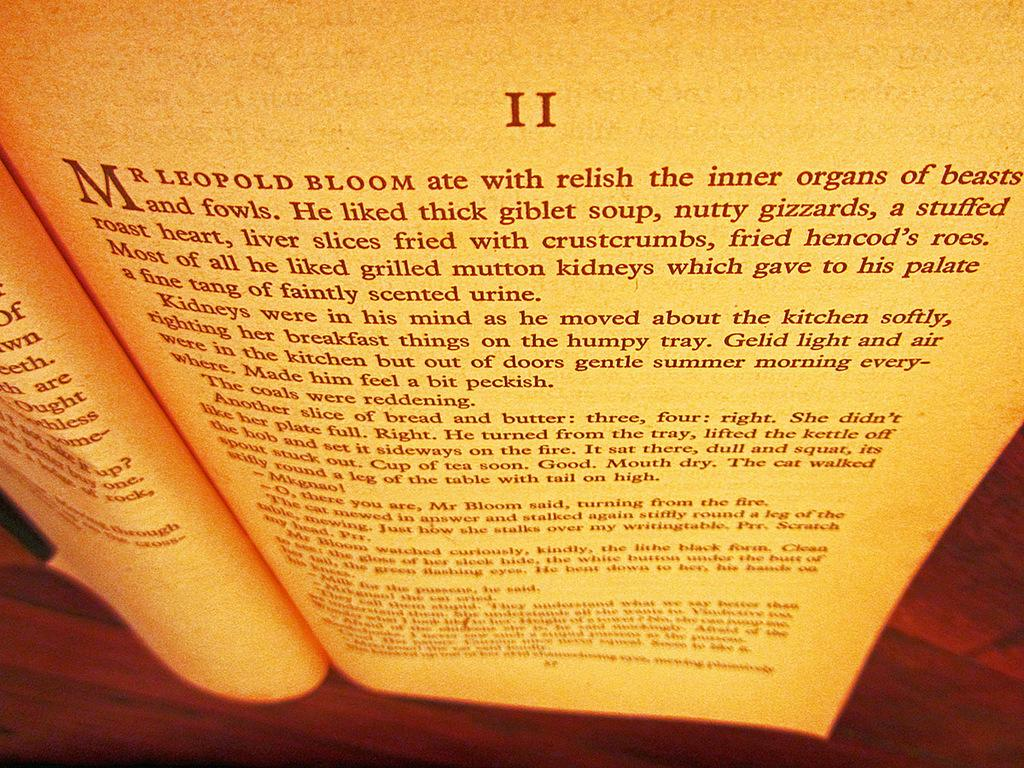<image>
Share a concise interpretation of the image provided. the name Leopold appears at the top of the pahge 